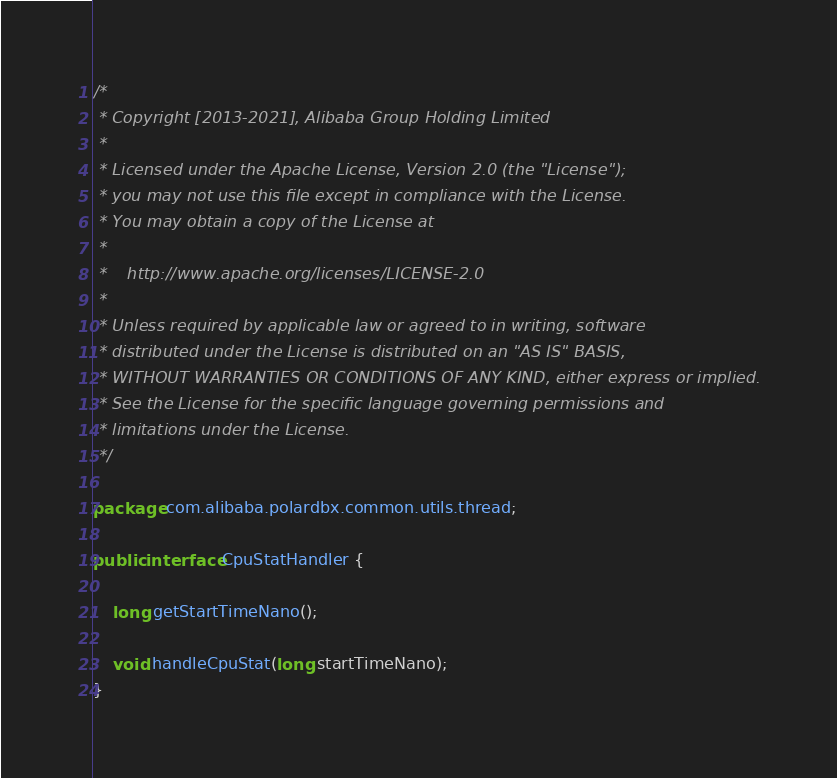<code> <loc_0><loc_0><loc_500><loc_500><_Java_>/*
 * Copyright [2013-2021], Alibaba Group Holding Limited
 *
 * Licensed under the Apache License, Version 2.0 (the "License");
 * you may not use this file except in compliance with the License.
 * You may obtain a copy of the License at
 *
 *    http://www.apache.org/licenses/LICENSE-2.0
 *
 * Unless required by applicable law or agreed to in writing, software
 * distributed under the License is distributed on an "AS IS" BASIS,
 * WITHOUT WARRANTIES OR CONDITIONS OF ANY KIND, either express or implied.
 * See the License for the specific language governing permissions and
 * limitations under the License.
 */

package com.alibaba.polardbx.common.utils.thread;

public interface CpuStatHandler {

    long getStartTimeNano();

    void handleCpuStat(long startTimeNano);
}
</code> 